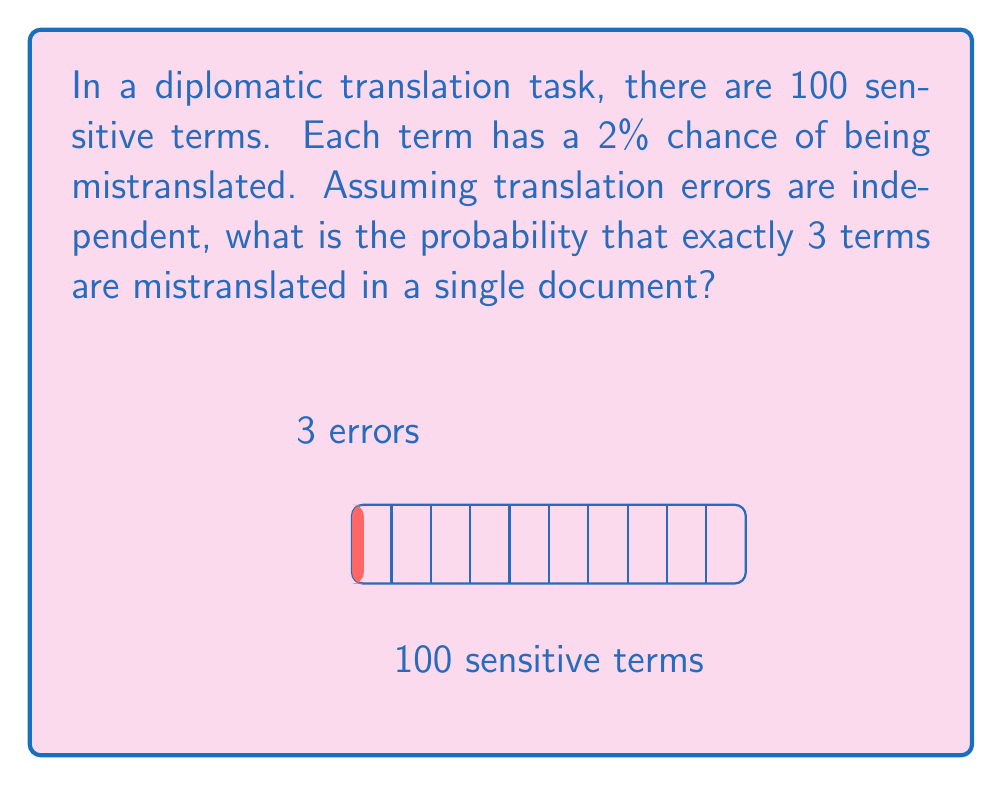Could you help me with this problem? To solve this problem, we can use the Binomial probability distribution:

1) Let X be the number of mistranslated terms.
2) X follows a Binomial distribution with n = 100 (total terms) and p = 0.02 (probability of mistranslation for each term).
3) We want to find P(X = 3).

The probability mass function for the Binomial distribution is:

$$ P(X = k) = \binom{n}{k} p^k (1-p)^{n-k} $$

Where:
- n = 100 (total number of terms)
- k = 3 (number of mistranslations we're interested in)
- p = 0.02 (probability of mistranslation for each term)

Plugging in these values:

$$ P(X = 3) = \binom{100}{3} (0.02)^3 (1-0.02)^{100-3} $$

$$ = \binom{100}{3} (0.02)^3 (0.98)^{97} $$

$$ = 161700 \times 0.000008 \times 0.0461 $$

$$ \approx 0.0596 $$

Therefore, the probability of exactly 3 terms being mistranslated is approximately 0.0596 or 5.96%.
Answer: $0.0596$ or $5.96\%$ 